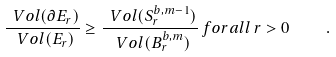<formula> <loc_0><loc_0><loc_500><loc_500>\frac { \ V o l ( \partial E _ { r } ) } { \ V o l ( E _ { r } ) } \geq \frac { \ V o l ( S ^ { b , m - 1 } _ { r } ) } { \ V o l ( B ^ { b , m } _ { r } ) } \, f o r a l l \, r > 0 \quad .</formula> 